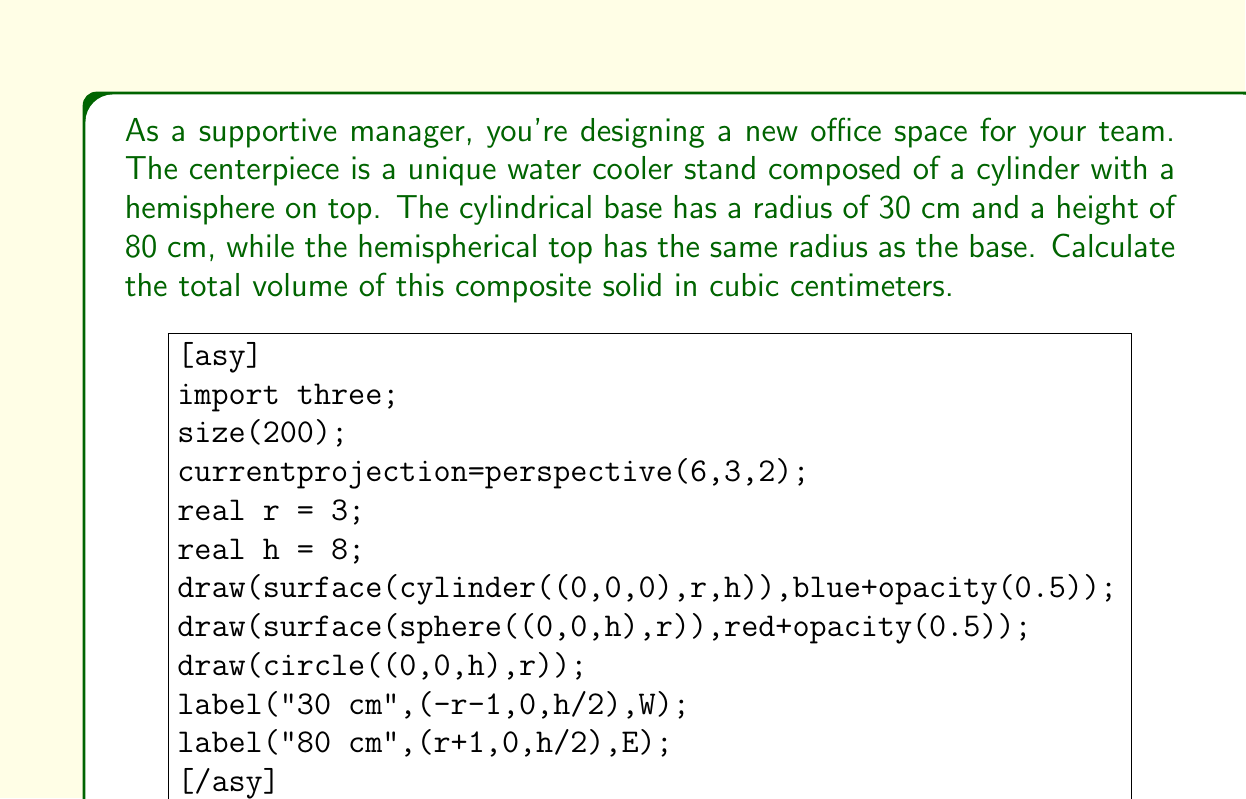What is the answer to this math problem? To calculate the total volume of this composite solid, we need to:
1. Calculate the volume of the cylindrical base
2. Calculate the volume of the hemispherical top
3. Sum these volumes

Step 1: Volume of the cylindrical base
The formula for the volume of a cylinder is $V_{cylinder} = \pi r^2 h$
$$V_{cylinder} = \pi \cdot (30\text{ cm})^2 \cdot 80\text{ cm} = 226,195.13\text{ cm}^3$$

Step 2: Volume of the hemispherical top
The formula for the volume of a hemisphere is $V_{hemisphere} = \frac{2}{3}\pi r^3$
$$V_{hemisphere} = \frac{2}{3}\pi \cdot (30\text{ cm})^3 = 56,548.78\text{ cm}^3$$

Step 3: Total volume
The total volume is the sum of the cylinder and hemisphere volumes:
$$V_{total} = V_{cylinder} + V_{hemisphere} = 226,195.13\text{ cm}^3 + 56,548.78\text{ cm}^3 = 282,743.91\text{ cm}^3$$

Rounding to the nearest cubic centimeter:
$$V_{total} \approx 282,744\text{ cm}^3$$
Answer: $282,744\text{ cm}^3$ 